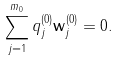Convert formula to latex. <formula><loc_0><loc_0><loc_500><loc_500>\sum _ { j = 1 } ^ { m _ { 0 } } q _ { j } ^ { ( 0 ) } { \mathbf w } _ { j } ^ { ( 0 ) } = 0 .</formula> 